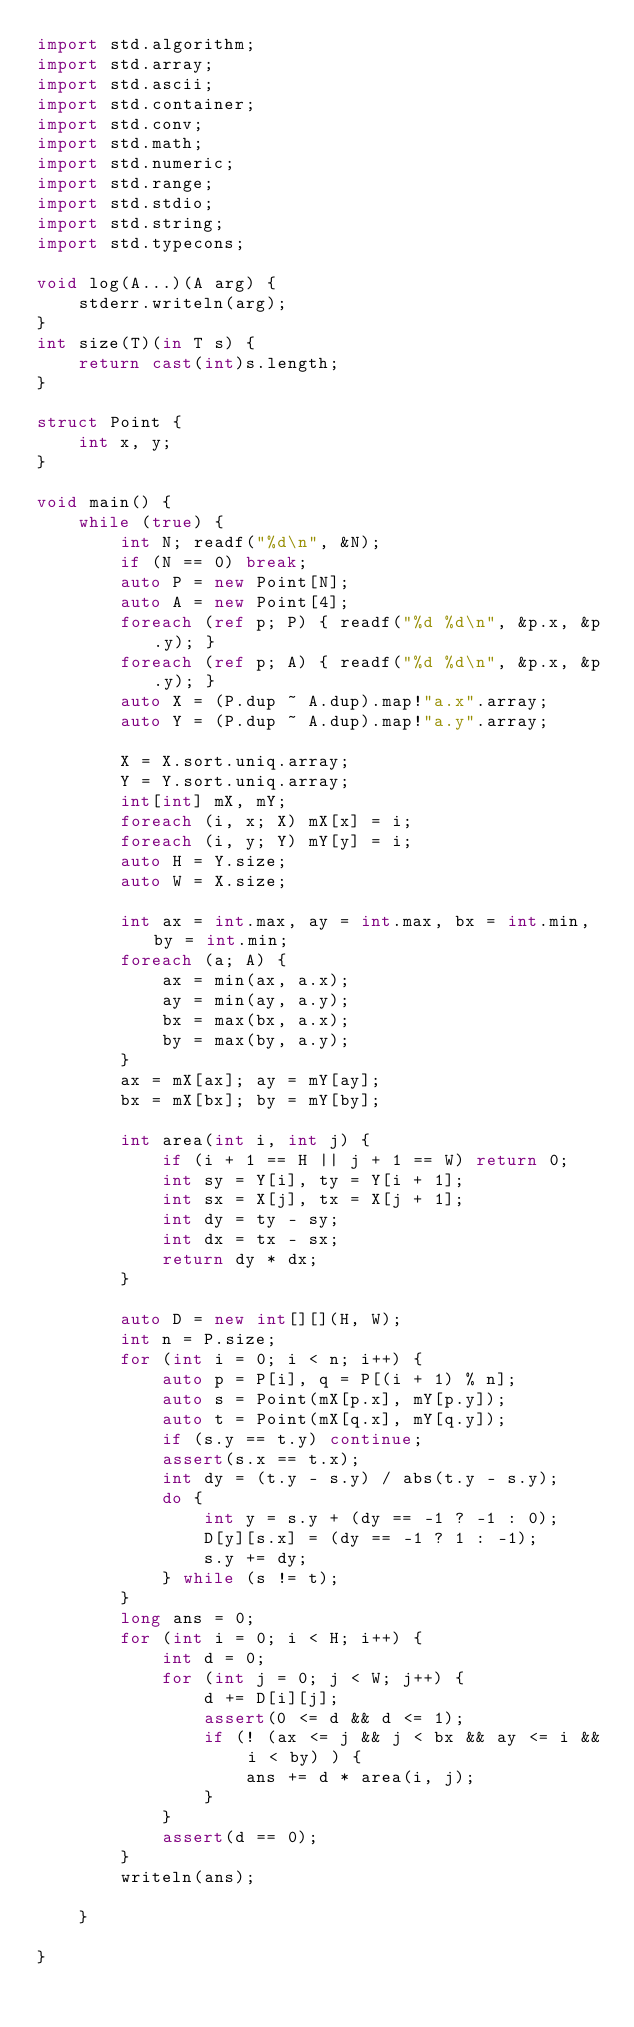<code> <loc_0><loc_0><loc_500><loc_500><_D_>import std.algorithm;
import std.array;
import std.ascii;
import std.container;
import std.conv;
import std.math;
import std.numeric;
import std.range;
import std.stdio;
import std.string;
import std.typecons;

void log(A...)(A arg) {
    stderr.writeln(arg);
}
int size(T)(in T s) {
    return cast(int)s.length;
}

struct Point {
    int x, y;
}

void main() {
    while (true) {
        int N; readf("%d\n", &N);
        if (N == 0) break;
        auto P = new Point[N];
        auto A = new Point[4];
        foreach (ref p; P) { readf("%d %d\n", &p.x, &p.y); }
        foreach (ref p; A) { readf("%d %d\n", &p.x, &p.y); }
        auto X = (P.dup ~ A.dup).map!"a.x".array;
        auto Y = (P.dup ~ A.dup).map!"a.y".array;

        X = X.sort.uniq.array;
        Y = Y.sort.uniq.array;
        int[int] mX, mY;
        foreach (i, x; X) mX[x] = i;
        foreach (i, y; Y) mY[y] = i;
        auto H = Y.size;
        auto W = X.size;

        int ax = int.max, ay = int.max, bx = int.min, by = int.min;
        foreach (a; A) {
            ax = min(ax, a.x);
            ay = min(ay, a.y);
            bx = max(bx, a.x);
            by = max(by, a.y);
        }
        ax = mX[ax]; ay = mY[ay];
        bx = mX[bx]; by = mY[by];

        int area(int i, int j) {
            if (i + 1 == H || j + 1 == W) return 0;
            int sy = Y[i], ty = Y[i + 1];
            int sx = X[j], tx = X[j + 1];
            int dy = ty - sy;
            int dx = tx - sx;
            return dy * dx;
        }

        auto D = new int[][](H, W);
        int n = P.size;
        for (int i = 0; i < n; i++) {
            auto p = P[i], q = P[(i + 1) % n];
            auto s = Point(mX[p.x], mY[p.y]);
            auto t = Point(mX[q.x], mY[q.y]);
            if (s.y == t.y) continue;
            assert(s.x == t.x);
            int dy = (t.y - s.y) / abs(t.y - s.y);
            do {
                int y = s.y + (dy == -1 ? -1 : 0);
                D[y][s.x] = (dy == -1 ? 1 : -1);
                s.y += dy;
            } while (s != t);
        }
        long ans = 0;
        for (int i = 0; i < H; i++) {
            int d = 0;
            for (int j = 0; j < W; j++) {
                d += D[i][j];
                assert(0 <= d && d <= 1);
                if (! (ax <= j && j < bx && ay <= i && i < by) ) {
                    ans += d * area(i, j);
                }
            }
            assert(d == 0);
        }
        writeln(ans);

    }

}</code> 